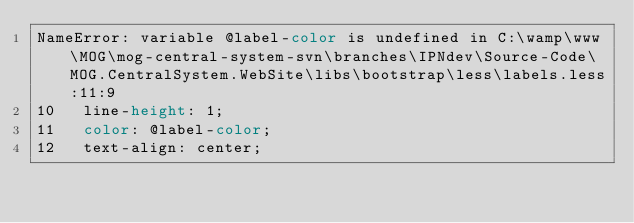Convert code to text. <code><loc_0><loc_0><loc_500><loc_500><_CSS_>NameError: variable @label-color is undefined in C:\wamp\www\MOG\mog-central-system-svn\branches\IPNdev\Source-Code\MOG.CentralSystem.WebSite\libs\bootstrap\less\labels.less:11:9
10   line-height: 1;
11   color: @label-color;
12   text-align: center;

</code> 